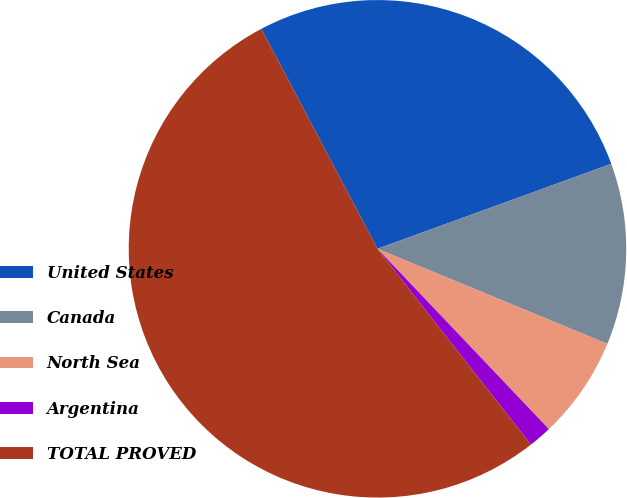<chart> <loc_0><loc_0><loc_500><loc_500><pie_chart><fcel>United States<fcel>Canada<fcel>North Sea<fcel>Argentina<fcel>TOTAL PROVED<nl><fcel>27.18%<fcel>11.79%<fcel>6.66%<fcel>1.52%<fcel>52.85%<nl></chart> 